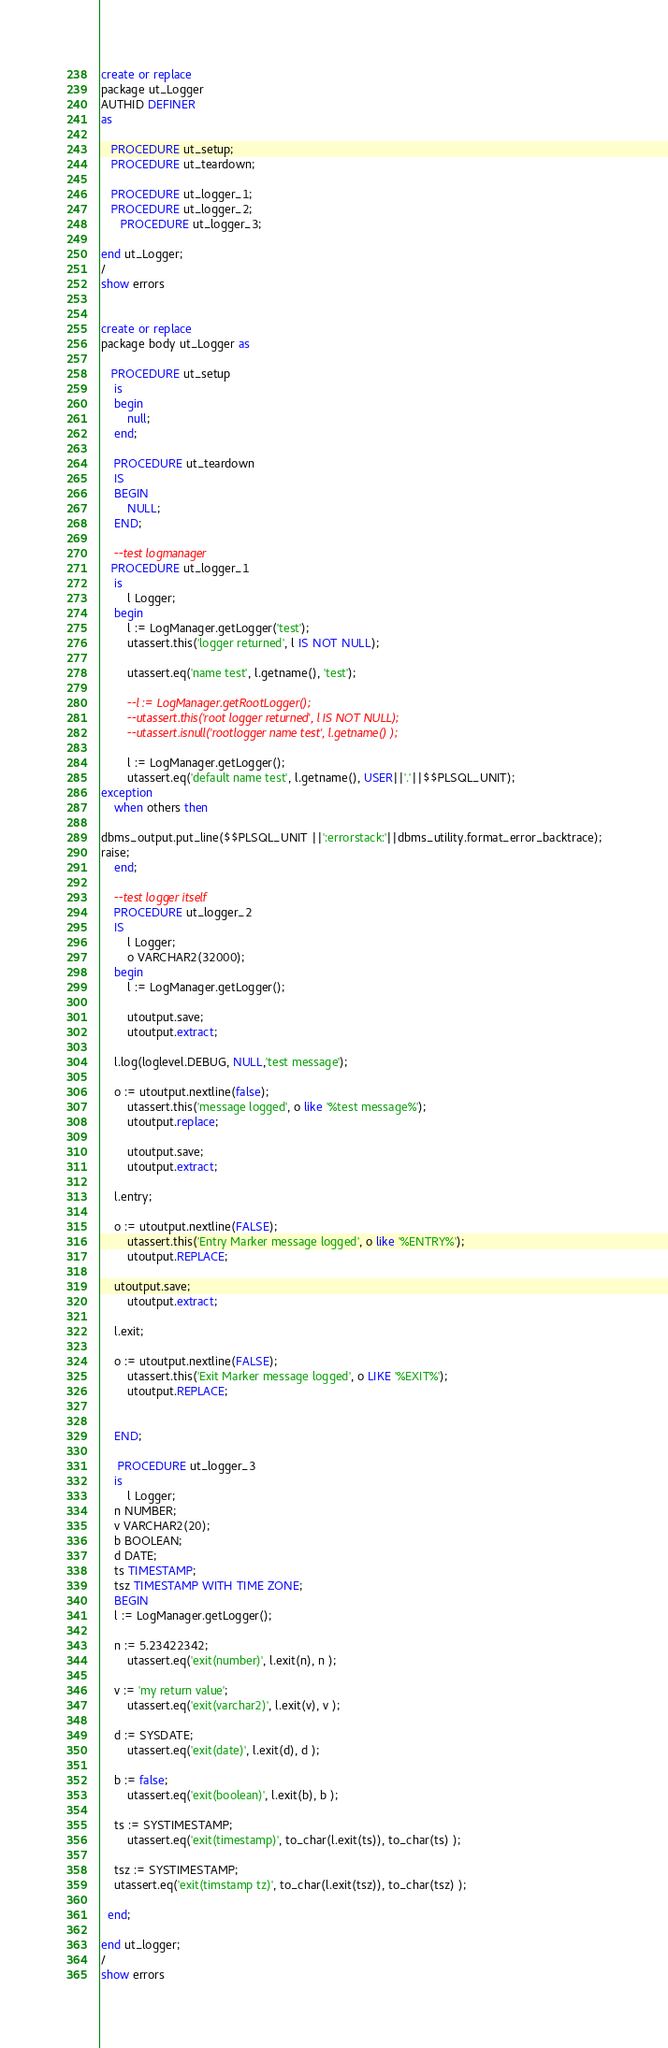Convert code to text. <code><loc_0><loc_0><loc_500><loc_500><_SQL_>create or replace 
package ut_Logger 
AUTHID DEFINER
as

   PROCEDURE ut_setup;
   PROCEDURE ut_teardown;
 
   PROCEDURE ut_logger_1;
   PROCEDURE ut_logger_2;
      PROCEDURE ut_logger_3;

end ut_Logger;
/
show errors


create or replace 
package body ut_Logger as

   PROCEDURE ut_setup
	is
	begin
		null;
	end;
  
	PROCEDURE ut_teardown
	IS
	BEGIN
		NULL;
	END;
 
	--test logmanager
   PROCEDURE ut_logger_1
	is
		l Logger;
	begin
		l := LogManager.getLogger('test');
		utassert.this('logger returned', l IS NOT NULL);

		utassert.eq('name test', l.getname(), 'test');

		--l := LogManager.getRootLogger();
		--utassert.this('root logger returned', l IS NOT NULL);
		--utassert.isnull('rootlogger name test', l.getname() );

		l := LogManager.getLogger();
		utassert.eq('default name test', l.getname(), USER||'.'||$$PLSQL_UNIT);
exception
	when others then
			
dbms_output.put_line($$PLSQL_UNIT ||':errorstack:'||dbms_utility.format_error_backtrace);
raise;
	end;

	--test logger itself
	PROCEDURE ut_logger_2
	IS
		l Logger;
		o VARCHAR2(32000);
	begin
		l := LogManager.getLogger();
    
		utoutput.save;
		utoutput.extract;
		
    l.log(loglevel.DEBUG, NULL,'test message');
		
    o := utoutput.nextline(false);
		utassert.this('message logged', o like '%test message%');
		utoutput.replace;

		utoutput.save;
		utoutput.extract;
		
    l.entry;
		
    o := utoutput.nextline(FALSE);
		utassert.this('Entry Marker message logged', o like '%ENTRY%');
		utoutput.REPLACE;
		
    utoutput.save;
		utoutput.extract;
		
    l.exit;
		
    o := utoutput.nextline(FALSE);
		utassert.this('Exit Marker message logged', o LIKE '%EXIT%');
		utoutput.REPLACE;
    

	END;
  
     PROCEDURE ut_logger_3
	is
		l Logger;
    n NUMBER;
    v VARCHAR2(20);
    b BOOLEAN;
    d DATE;
    ts TIMESTAMP;
    tsz TIMESTAMP WITH TIME ZONE;
	BEGIN
  	l := LogManager.getLogger();
    
    n := 5.23422342;
    	utassert.eq('exit(number)', l.exit(n), n );

    v := 'my return value';
    	utassert.eq('exit(varchar2)', l.exit(v), v );

    d := SYSDATE;
    	utassert.eq('exit(date)', l.exit(d), d );

    b := false;
    	utassert.eq('exit(boolean)', l.exit(b), b );

    ts := SYSTIMESTAMP;
    	utassert.eq('exit(timestamp)', to_char(l.exit(ts)), to_char(ts) );

    tsz := SYSTIMESTAMP;
    utassert.eq('exit(timstamp tz)', to_char(l.exit(tsz)), to_char(tsz) );
    
  end;

end ut_logger;
/
show errors

</code> 